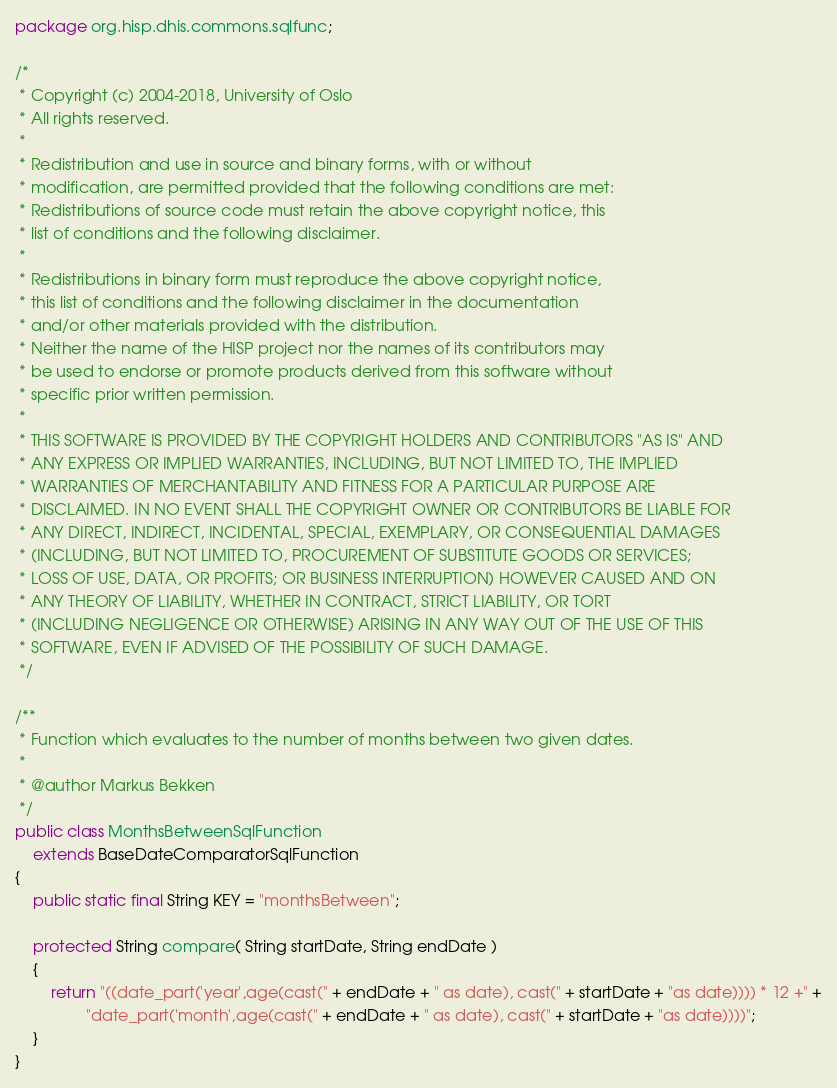<code> <loc_0><loc_0><loc_500><loc_500><_Java_>package org.hisp.dhis.commons.sqlfunc;

/*
 * Copyright (c) 2004-2018, University of Oslo
 * All rights reserved.
 *
 * Redistribution and use in source and binary forms, with or without
 * modification, are permitted provided that the following conditions are met:
 * Redistributions of source code must retain the above copyright notice, this
 * list of conditions and the following disclaimer.
 *
 * Redistributions in binary form must reproduce the above copyright notice,
 * this list of conditions and the following disclaimer in the documentation
 * and/or other materials provided with the distribution.
 * Neither the name of the HISP project nor the names of its contributors may
 * be used to endorse or promote products derived from this software without
 * specific prior written permission.
 *
 * THIS SOFTWARE IS PROVIDED BY THE COPYRIGHT HOLDERS AND CONTRIBUTORS "AS IS" AND
 * ANY EXPRESS OR IMPLIED WARRANTIES, INCLUDING, BUT NOT LIMITED TO, THE IMPLIED
 * WARRANTIES OF MERCHANTABILITY AND FITNESS FOR A PARTICULAR PURPOSE ARE
 * DISCLAIMED. IN NO EVENT SHALL THE COPYRIGHT OWNER OR CONTRIBUTORS BE LIABLE FOR
 * ANY DIRECT, INDIRECT, INCIDENTAL, SPECIAL, EXEMPLARY, OR CONSEQUENTIAL DAMAGES
 * (INCLUDING, BUT NOT LIMITED TO, PROCUREMENT OF SUBSTITUTE GOODS OR SERVICES;
 * LOSS OF USE, DATA, OR PROFITS; OR BUSINESS INTERRUPTION) HOWEVER CAUSED AND ON
 * ANY THEORY OF LIABILITY, WHETHER IN CONTRACT, STRICT LIABILITY, OR TORT
 * (INCLUDING NEGLIGENCE OR OTHERWISE) ARISING IN ANY WAY OUT OF THE USE OF THIS
 * SOFTWARE, EVEN IF ADVISED OF THE POSSIBILITY OF SUCH DAMAGE.
 */

/**
 * Function which evaluates to the number of months between two given dates.
 * 
 * @author Markus Bekken
 */
public class MonthsBetweenSqlFunction
    extends BaseDateComparatorSqlFunction
{
    public static final String KEY = "monthsBetween";
    
    protected String compare( String startDate, String endDate )
    {
        return "((date_part('year',age(cast(" + endDate + " as date), cast(" + startDate + "as date)))) * 12 +" +
                "date_part('month',age(cast(" + endDate + " as date), cast(" + startDate + "as date))))";
    }
}
</code> 